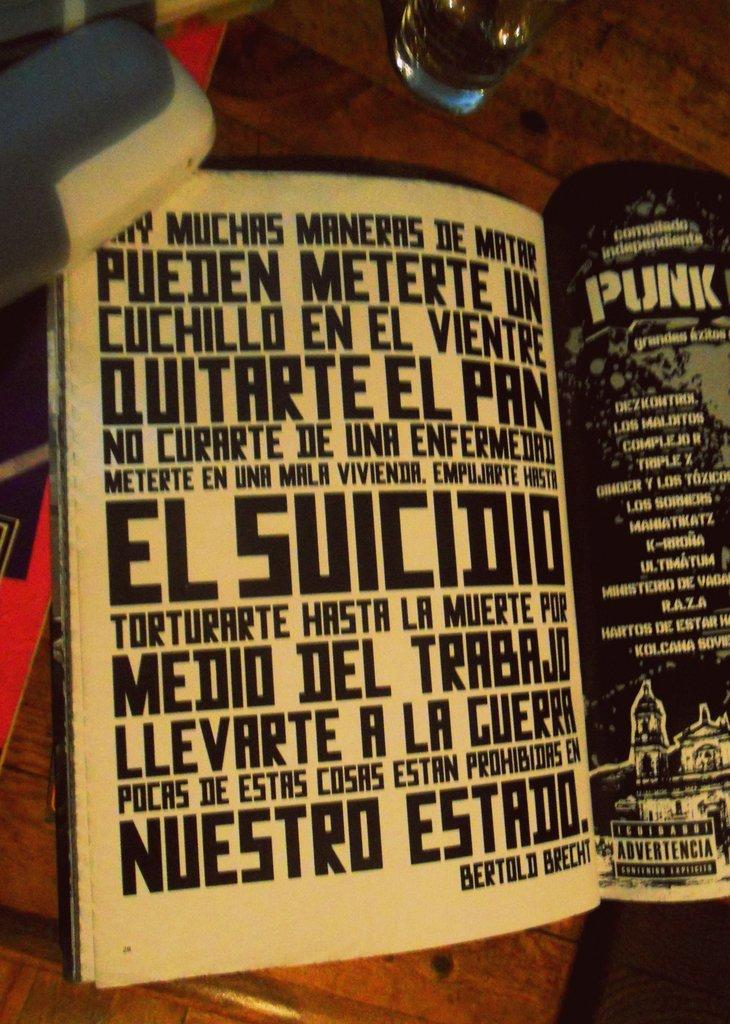<image>
Offer a succinct explanation of the picture presented. An open book showing two pages of written text and on the bottom of the first page says Bertold Breecht. 